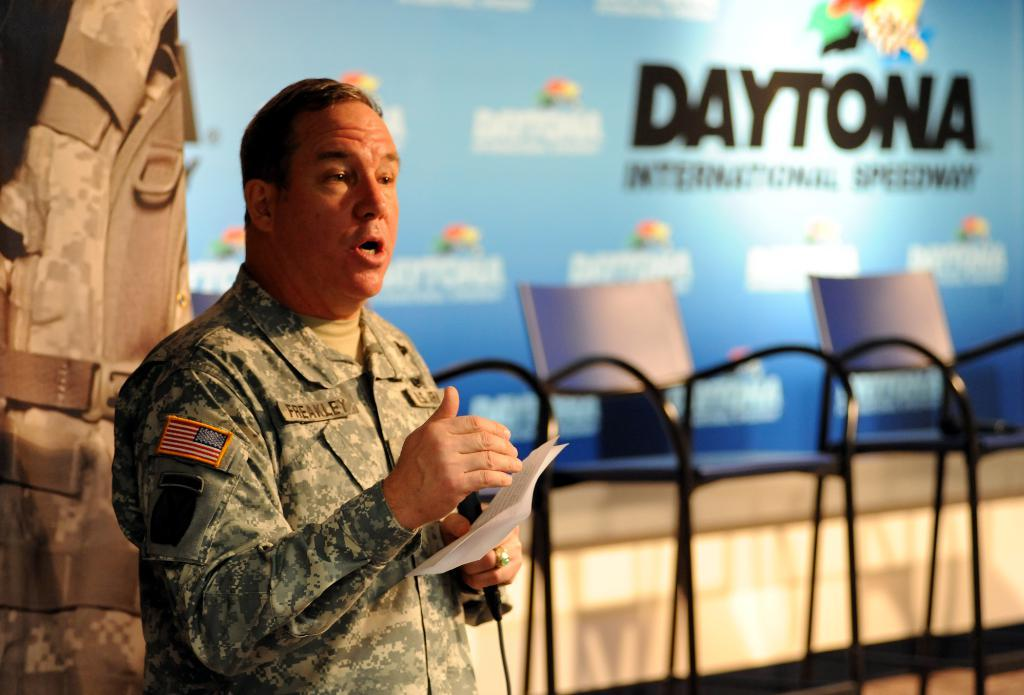What is the person in the image doing? The person is standing in the image and holding papers. What is the person wearing? The person is wearing a green color uniform. What can be seen in the background of the image? There are chairs and a banner in blue color visible in the background. What type of system is the person using to hold the papers in the image? There is no specific system mentioned or visible in the image for holding the papers; the person is simply holding them. 